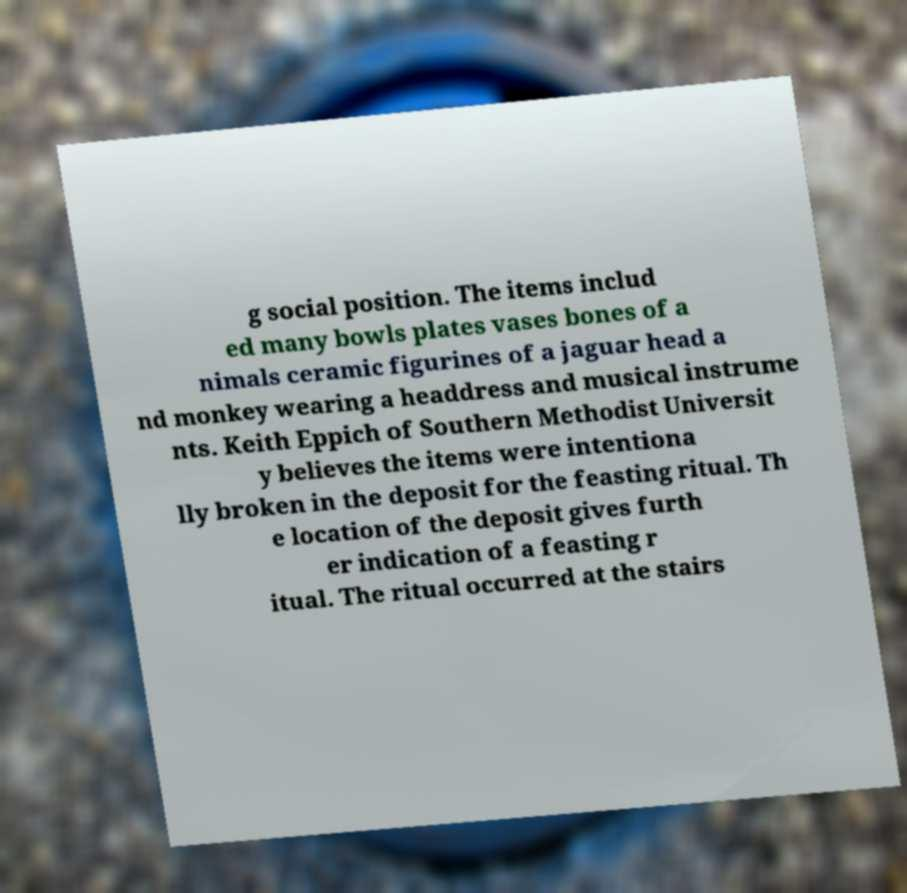Please read and relay the text visible in this image. What does it say? g social position. The items includ ed many bowls plates vases bones of a nimals ceramic figurines of a jaguar head a nd monkey wearing a headdress and musical instrume nts. Keith Eppich of Southern Methodist Universit y believes the items were intentiona lly broken in the deposit for the feasting ritual. Th e location of the deposit gives furth er indication of a feasting r itual. The ritual occurred at the stairs 